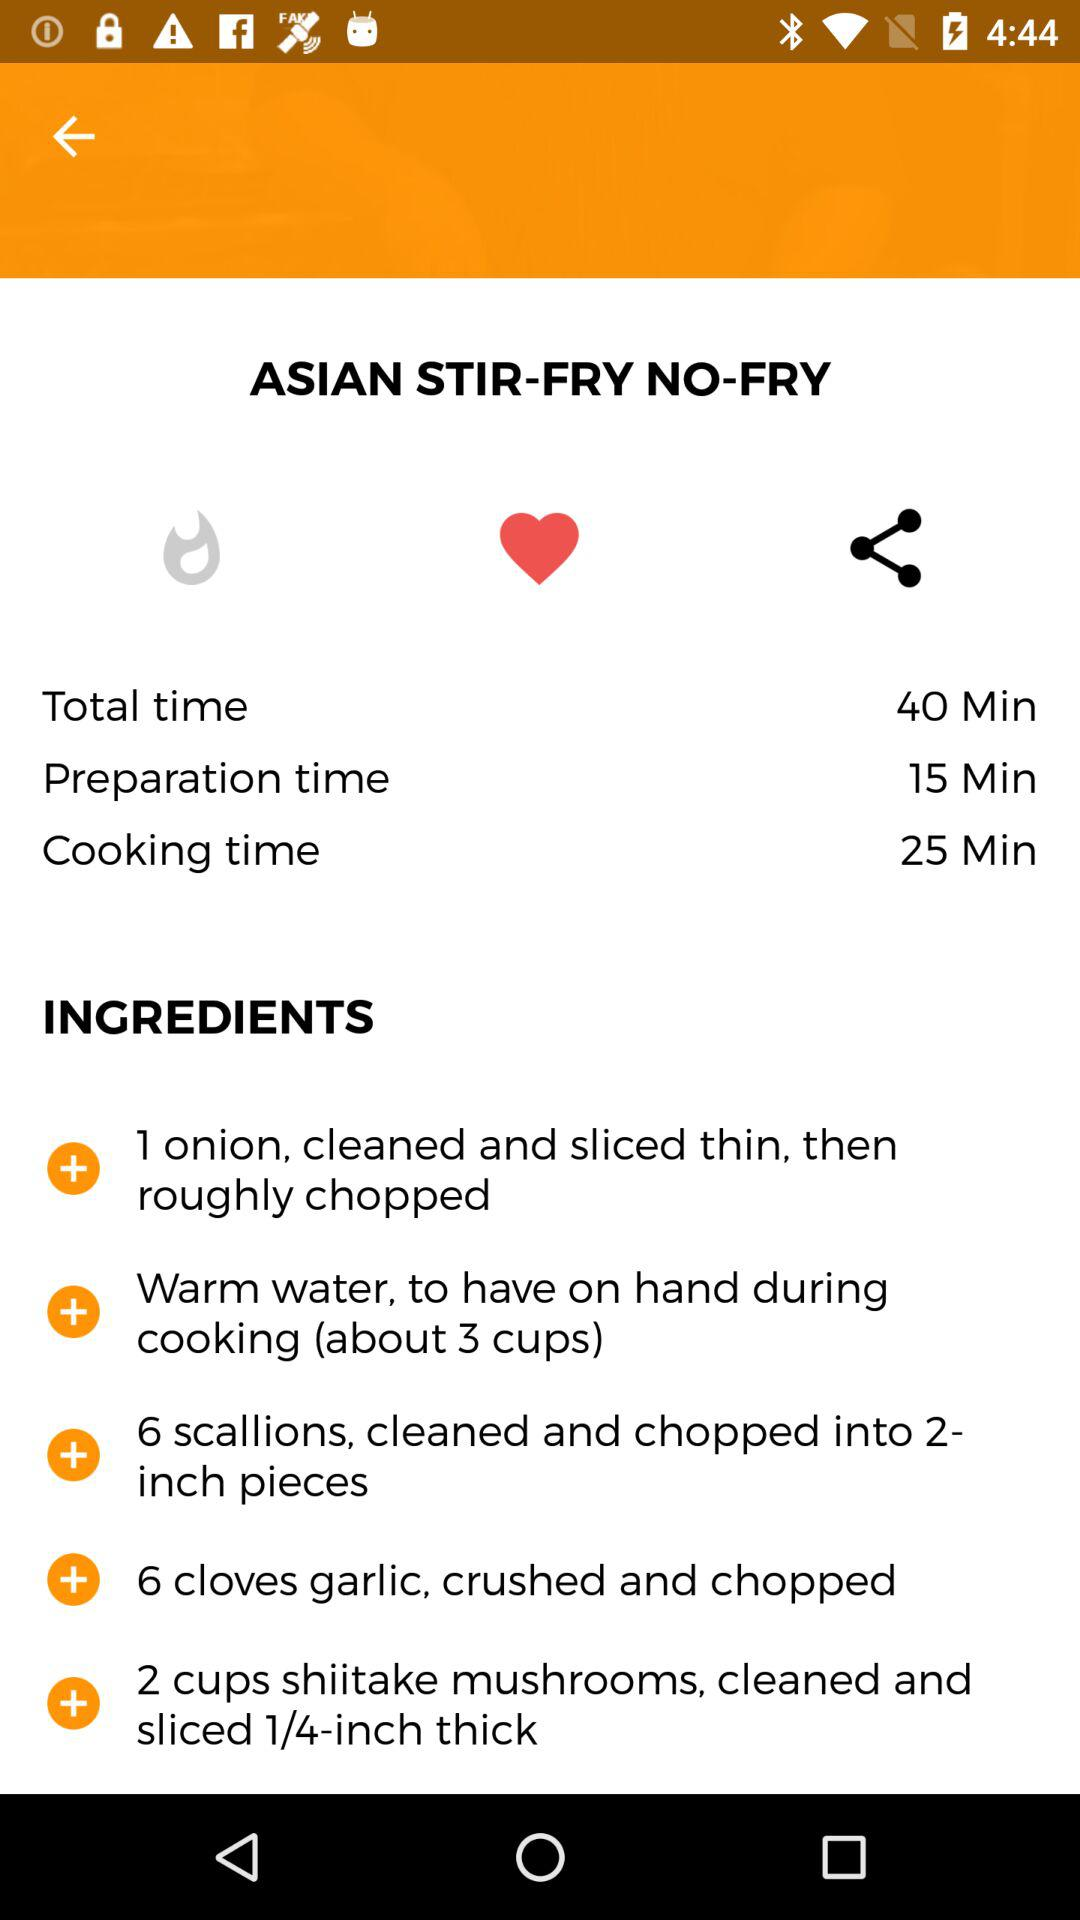How much garlic is to be used for the recipe? The amount of garlic that is to be used is 6 cloves. 